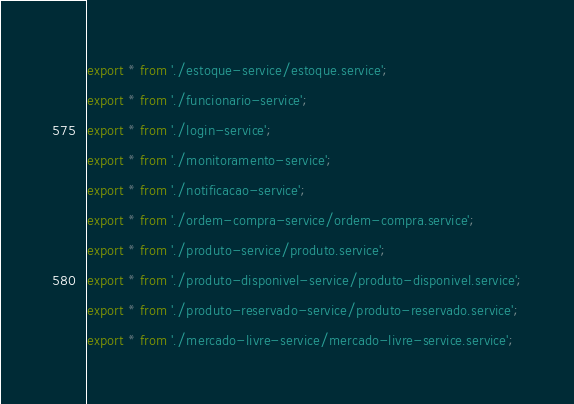Convert code to text. <code><loc_0><loc_0><loc_500><loc_500><_TypeScript_>export * from './estoque-service/estoque.service';
export * from './funcionario-service';
export * from './login-service';
export * from './monitoramento-service';
export * from './notificacao-service';
export * from './ordem-compra-service/ordem-compra.service';
export * from './produto-service/produto.service';
export * from './produto-disponivel-service/produto-disponivel.service';
export * from './produto-reservado-service/produto-reservado.service';
export * from './mercado-livre-service/mercado-livre-service.service';
</code> 